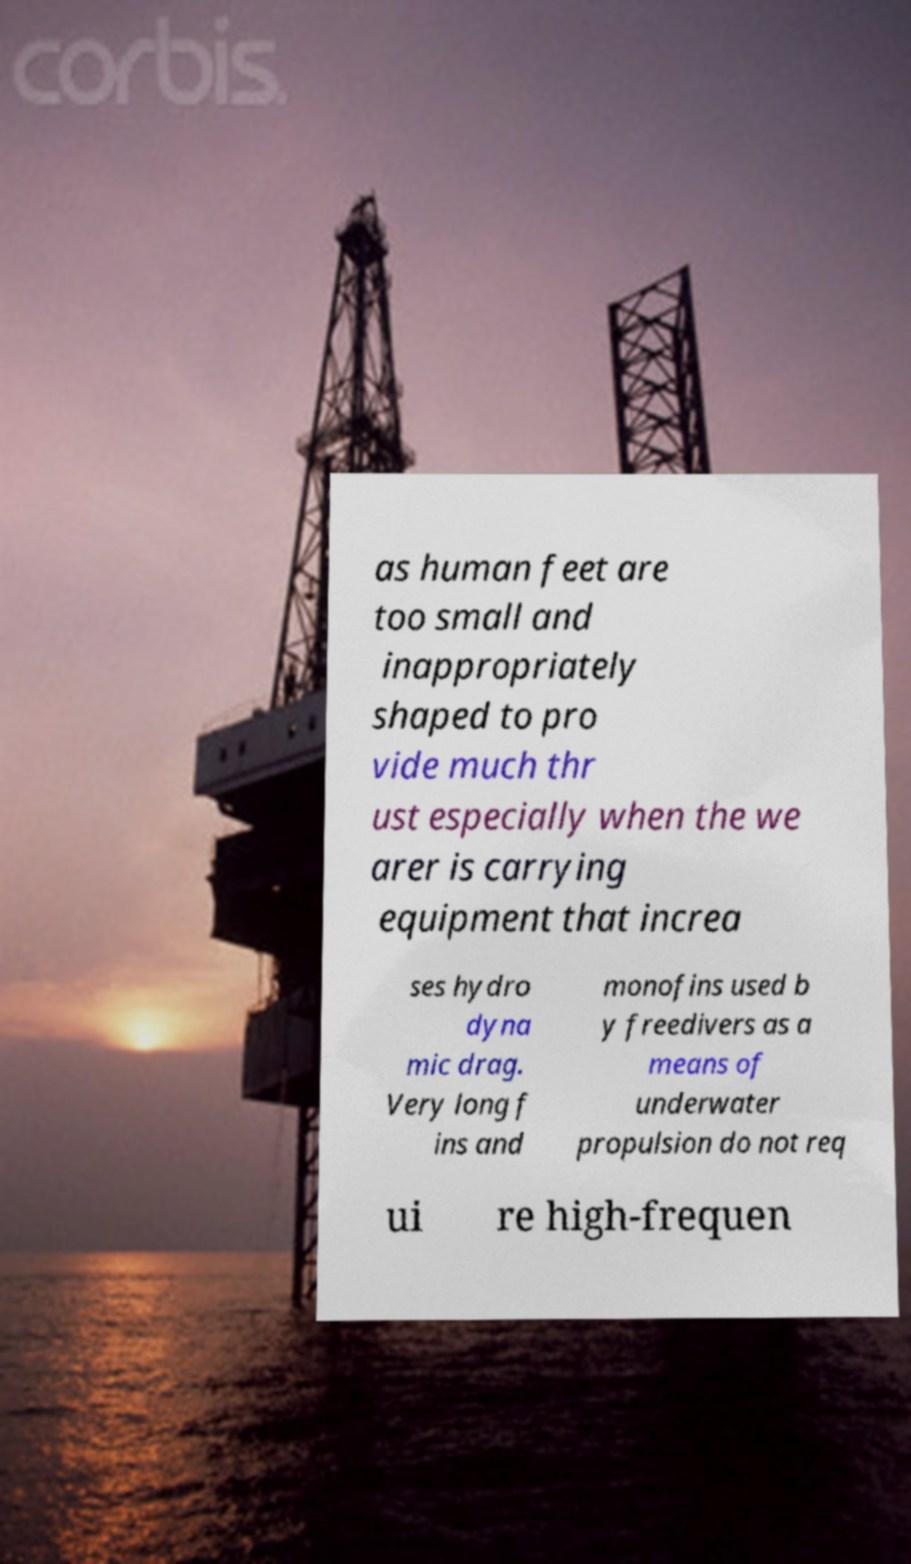What messages or text are displayed in this image? I need them in a readable, typed format. as human feet are too small and inappropriately shaped to pro vide much thr ust especially when the we arer is carrying equipment that increa ses hydro dyna mic drag. Very long f ins and monofins used b y freedivers as a means of underwater propulsion do not req ui re high-frequen 